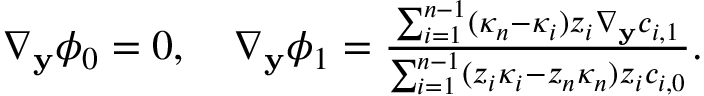Convert formula to latex. <formula><loc_0><loc_0><loc_500><loc_500>\begin{array} { r } { \nabla _ { y } \phi _ { 0 } = 0 , \quad \nabla _ { y } \phi _ { 1 } = \frac { \sum _ { i = 1 } ^ { n - 1 } ( \kappa _ { n } - \kappa _ { i } ) z _ { i } \nabla _ { y } c _ { i , 1 } } { \sum _ { i = 1 } ^ { n - 1 } ( z _ { i } \kappa _ { i } - z _ { n } \kappa _ { n } ) z _ { i } c _ { i , 0 } } . } \end{array}</formula> 